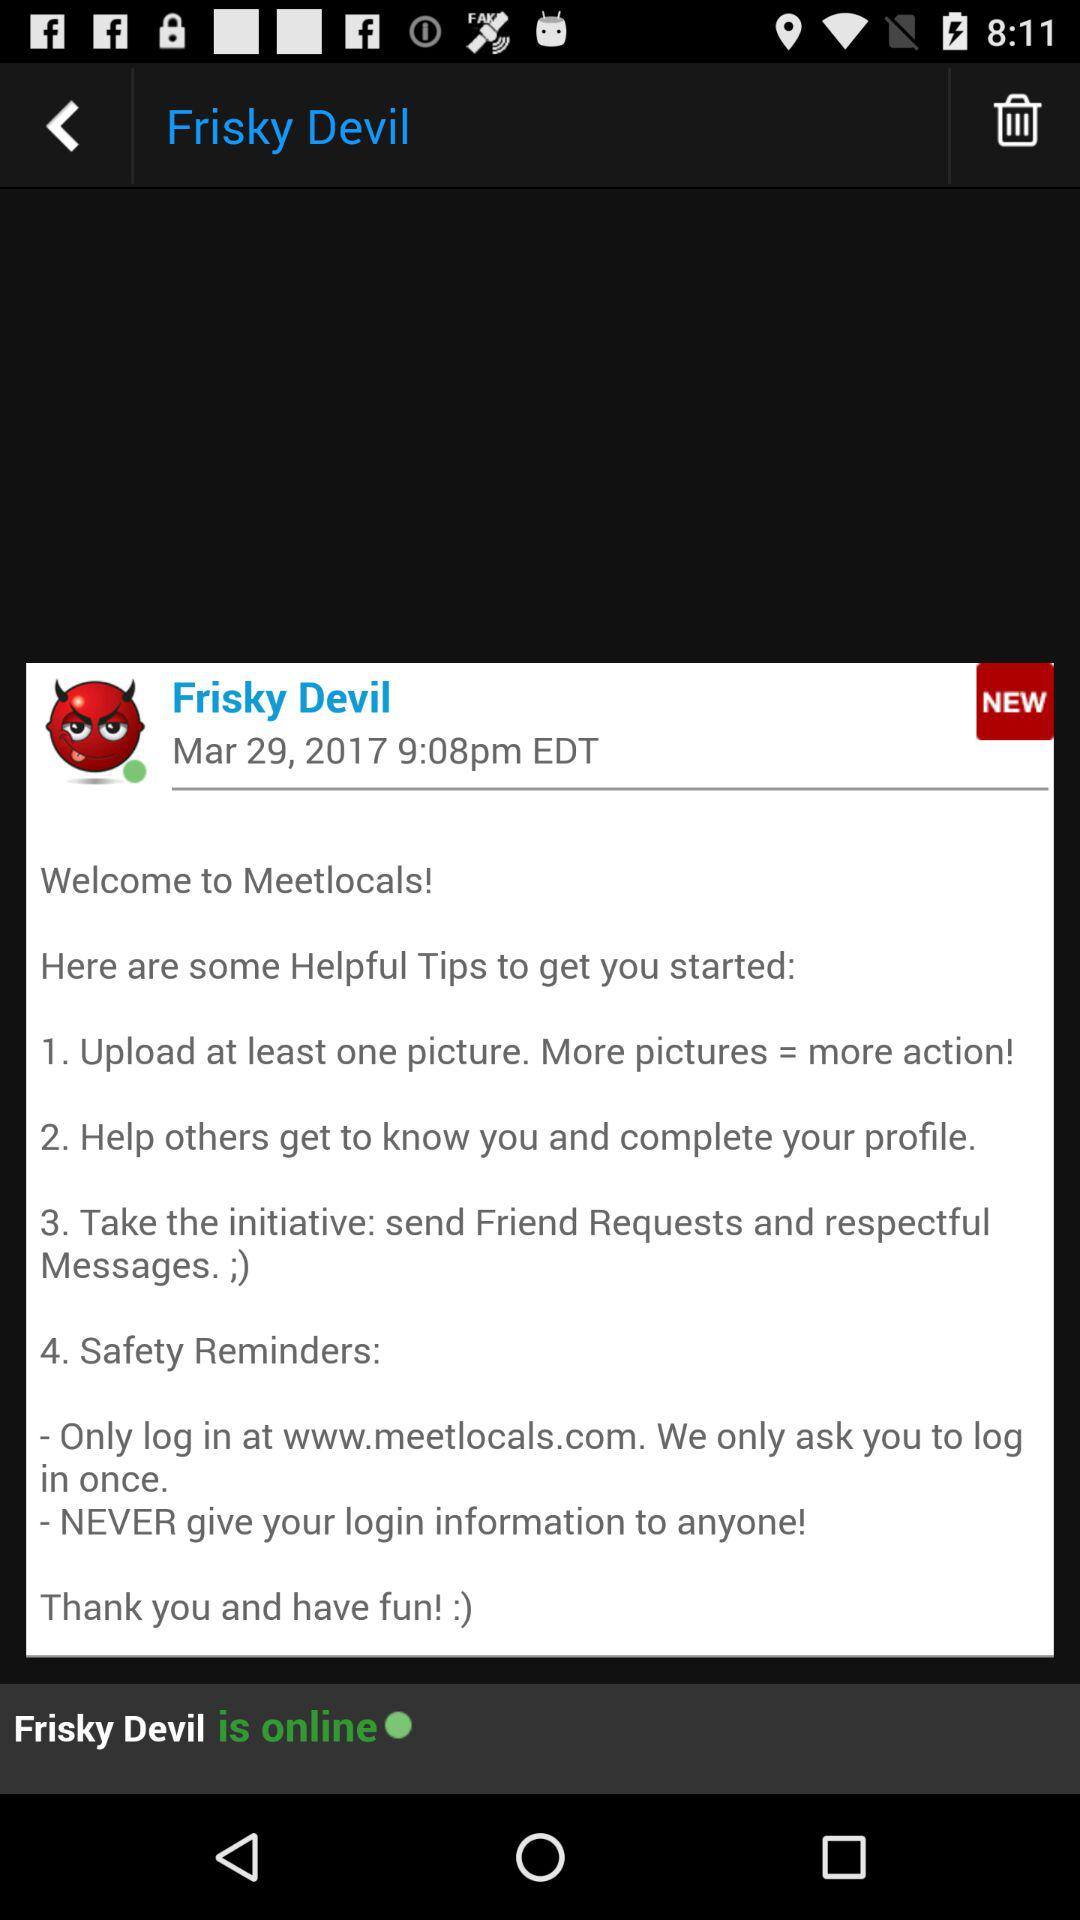What is the date? The date is March 29, 2017. 